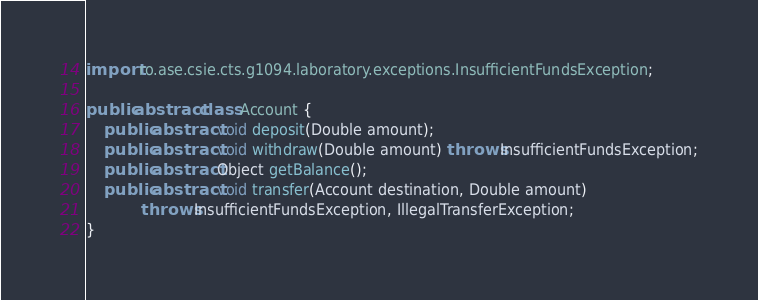<code> <loc_0><loc_0><loc_500><loc_500><_Java_>import ro.ase.csie.cts.g1094.laboratory.exceptions.InsufficientFundsException;

public abstract class Account {
	public abstract void deposit(Double amount);
	public abstract void withdraw(Double amount) throws InsufficientFundsException;
	public abstract Object getBalance();
	public abstract void transfer(Account destination, Double amount) 
			throws InsufficientFundsException, IllegalTransferException;
}
</code> 